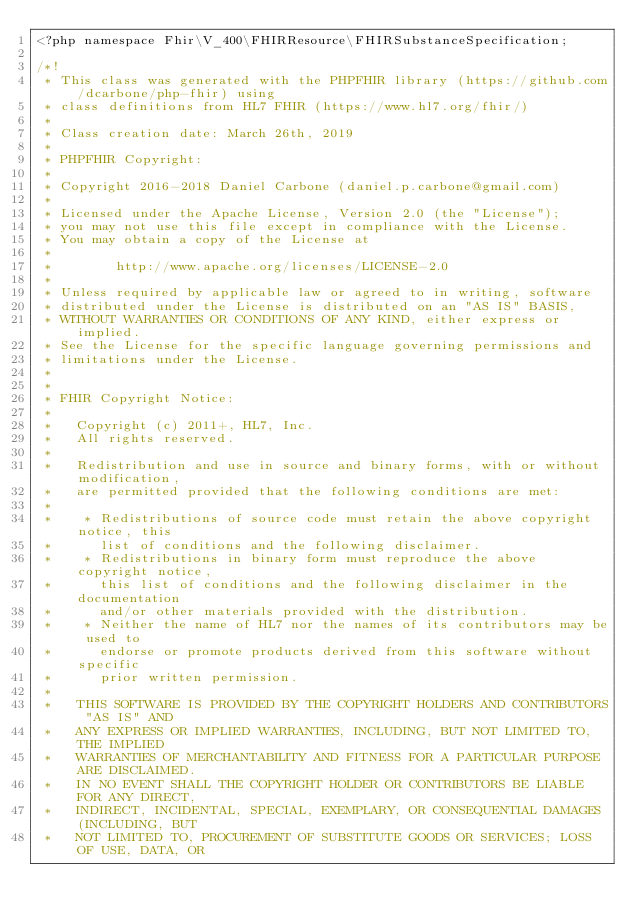Convert code to text. <code><loc_0><loc_0><loc_500><loc_500><_PHP_><?php namespace Fhir\V_400\FHIRResource\FHIRSubstanceSpecification;

/*!
 * This class was generated with the PHPFHIR library (https://github.com/dcarbone/php-fhir) using
 * class definitions from HL7 FHIR (https://www.hl7.org/fhir/)
 * 
 * Class creation date: March 26th, 2019
 * 
 * PHPFHIR Copyright:
 * 
 * Copyright 2016-2018 Daniel Carbone (daniel.p.carbone@gmail.com)
 * 
 * Licensed under the Apache License, Version 2.0 (the "License");
 * you may not use this file except in compliance with the License.
 * You may obtain a copy of the License at
 * 
 *        http://www.apache.org/licenses/LICENSE-2.0
 * 
 * Unless required by applicable law or agreed to in writing, software
 * distributed under the License is distributed on an "AS IS" BASIS,
 * WITHOUT WARRANTIES OR CONDITIONS OF ANY KIND, either express or implied.
 * See the License for the specific language governing permissions and
 * limitations under the License.
 * 
 *
 * FHIR Copyright Notice:
 *
 *   Copyright (c) 2011+, HL7, Inc.
 *   All rights reserved.
 * 
 *   Redistribution and use in source and binary forms, with or without modification,
 *   are permitted provided that the following conditions are met:
 * 
 *    * Redistributions of source code must retain the above copyright notice, this
 *      list of conditions and the following disclaimer.
 *    * Redistributions in binary form must reproduce the above copyright notice,
 *      this list of conditions and the following disclaimer in the documentation
 *      and/or other materials provided with the distribution.
 *    * Neither the name of HL7 nor the names of its contributors may be used to
 *      endorse or promote products derived from this software without specific
 *      prior written permission.
 * 
 *   THIS SOFTWARE IS PROVIDED BY THE COPYRIGHT HOLDERS AND CONTRIBUTORS "AS IS" AND
 *   ANY EXPRESS OR IMPLIED WARRANTIES, INCLUDING, BUT NOT LIMITED TO, THE IMPLIED
 *   WARRANTIES OF MERCHANTABILITY AND FITNESS FOR A PARTICULAR PURPOSE ARE DISCLAIMED.
 *   IN NO EVENT SHALL THE COPYRIGHT HOLDER OR CONTRIBUTORS BE LIABLE FOR ANY DIRECT,
 *   INDIRECT, INCIDENTAL, SPECIAL, EXEMPLARY, OR CONSEQUENTIAL DAMAGES (INCLUDING, BUT
 *   NOT LIMITED TO, PROCUREMENT OF SUBSTITUTE GOODS OR SERVICES; LOSS OF USE, DATA, OR</code> 